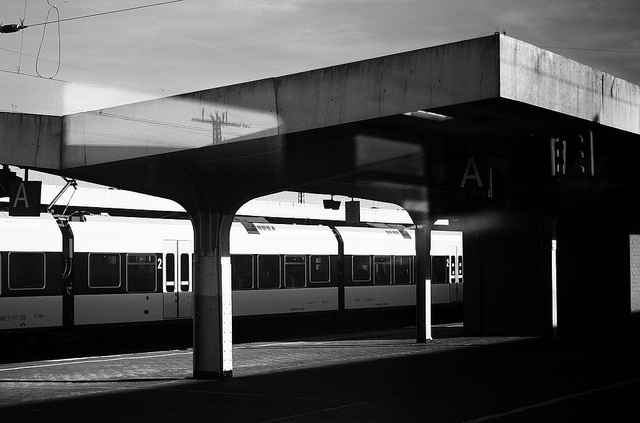Describe the objects in this image and their specific colors. I can see a train in darkgray, black, whitesmoke, and gray tones in this image. 